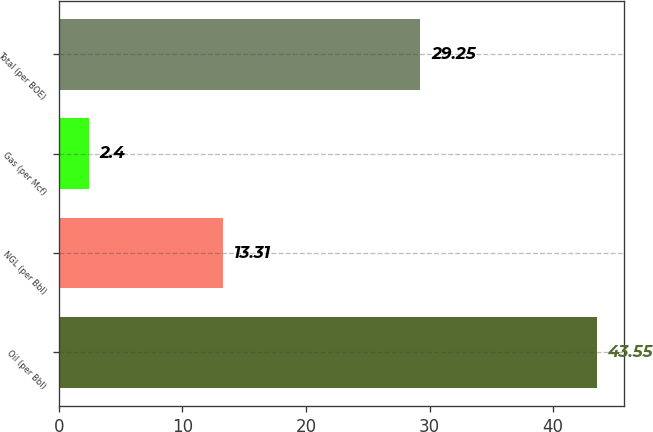Convert chart. <chart><loc_0><loc_0><loc_500><loc_500><bar_chart><fcel>Oil (per Bbl)<fcel>NGL (per Bbl)<fcel>Gas (per Mcf)<fcel>Total (per BOE)<nl><fcel>43.55<fcel>13.31<fcel>2.4<fcel>29.25<nl></chart> 